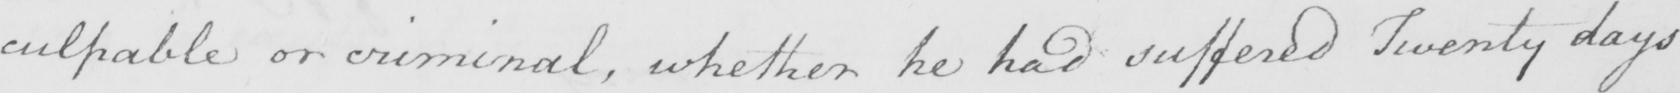Can you tell me what this handwritten text says? culpable or criminal , whether he had suffered Twenty days 